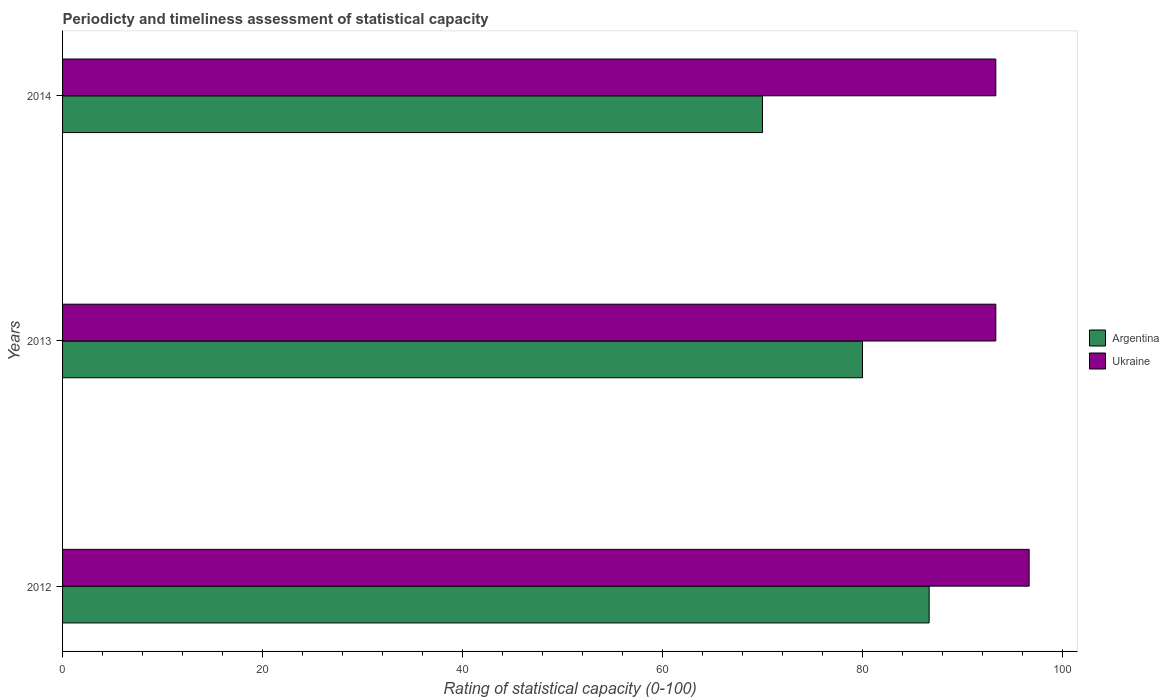How many different coloured bars are there?
Ensure brevity in your answer.  2. Are the number of bars per tick equal to the number of legend labels?
Give a very brief answer. Yes. What is the label of the 1st group of bars from the top?
Offer a very short reply. 2014. In how many cases, is the number of bars for a given year not equal to the number of legend labels?
Your response must be concise. 0. What is the rating of statistical capacity in Ukraine in 2012?
Your answer should be compact. 96.67. Across all years, what is the maximum rating of statistical capacity in Ukraine?
Offer a terse response. 96.67. Across all years, what is the minimum rating of statistical capacity in Ukraine?
Your answer should be very brief. 93.33. In which year was the rating of statistical capacity in Ukraine maximum?
Offer a very short reply. 2012. What is the total rating of statistical capacity in Argentina in the graph?
Offer a very short reply. 236.67. What is the difference between the rating of statistical capacity in Ukraine in 2012 and that in 2014?
Make the answer very short. 3.33. What is the difference between the rating of statistical capacity in Ukraine in 2014 and the rating of statistical capacity in Argentina in 2012?
Your answer should be compact. 6.67. What is the average rating of statistical capacity in Ukraine per year?
Make the answer very short. 94.44. In the year 2013, what is the difference between the rating of statistical capacity in Argentina and rating of statistical capacity in Ukraine?
Your answer should be compact. -13.33. What is the difference between the highest and the second highest rating of statistical capacity in Argentina?
Offer a very short reply. 6.67. What is the difference between the highest and the lowest rating of statistical capacity in Ukraine?
Provide a succinct answer. 3.33. In how many years, is the rating of statistical capacity in Argentina greater than the average rating of statistical capacity in Argentina taken over all years?
Offer a terse response. 2. What does the 2nd bar from the top in 2014 represents?
Provide a short and direct response. Argentina. What does the 2nd bar from the bottom in 2013 represents?
Your answer should be very brief. Ukraine. How many bars are there?
Provide a succinct answer. 6. Are all the bars in the graph horizontal?
Keep it short and to the point. Yes. How many years are there in the graph?
Provide a short and direct response. 3. Are the values on the major ticks of X-axis written in scientific E-notation?
Provide a succinct answer. No. Does the graph contain any zero values?
Make the answer very short. No. Does the graph contain grids?
Your answer should be compact. No. Where does the legend appear in the graph?
Provide a succinct answer. Center right. How are the legend labels stacked?
Provide a succinct answer. Vertical. What is the title of the graph?
Keep it short and to the point. Periodicty and timeliness assessment of statistical capacity. What is the label or title of the X-axis?
Offer a terse response. Rating of statistical capacity (0-100). What is the label or title of the Y-axis?
Your answer should be compact. Years. What is the Rating of statistical capacity (0-100) of Argentina in 2012?
Give a very brief answer. 86.67. What is the Rating of statistical capacity (0-100) of Ukraine in 2012?
Give a very brief answer. 96.67. What is the Rating of statistical capacity (0-100) in Ukraine in 2013?
Keep it short and to the point. 93.33. What is the Rating of statistical capacity (0-100) in Argentina in 2014?
Offer a very short reply. 70. What is the Rating of statistical capacity (0-100) in Ukraine in 2014?
Your answer should be very brief. 93.33. Across all years, what is the maximum Rating of statistical capacity (0-100) of Argentina?
Provide a succinct answer. 86.67. Across all years, what is the maximum Rating of statistical capacity (0-100) in Ukraine?
Keep it short and to the point. 96.67. Across all years, what is the minimum Rating of statistical capacity (0-100) in Ukraine?
Provide a short and direct response. 93.33. What is the total Rating of statistical capacity (0-100) of Argentina in the graph?
Offer a terse response. 236.67. What is the total Rating of statistical capacity (0-100) of Ukraine in the graph?
Offer a terse response. 283.33. What is the difference between the Rating of statistical capacity (0-100) in Ukraine in 2012 and that in 2013?
Make the answer very short. 3.33. What is the difference between the Rating of statistical capacity (0-100) in Argentina in 2012 and that in 2014?
Provide a short and direct response. 16.67. What is the difference between the Rating of statistical capacity (0-100) in Ukraine in 2012 and that in 2014?
Give a very brief answer. 3.33. What is the difference between the Rating of statistical capacity (0-100) of Argentina in 2012 and the Rating of statistical capacity (0-100) of Ukraine in 2013?
Offer a terse response. -6.67. What is the difference between the Rating of statistical capacity (0-100) in Argentina in 2012 and the Rating of statistical capacity (0-100) in Ukraine in 2014?
Offer a very short reply. -6.67. What is the difference between the Rating of statistical capacity (0-100) of Argentina in 2013 and the Rating of statistical capacity (0-100) of Ukraine in 2014?
Provide a short and direct response. -13.33. What is the average Rating of statistical capacity (0-100) of Argentina per year?
Ensure brevity in your answer.  78.89. What is the average Rating of statistical capacity (0-100) of Ukraine per year?
Ensure brevity in your answer.  94.44. In the year 2013, what is the difference between the Rating of statistical capacity (0-100) in Argentina and Rating of statistical capacity (0-100) in Ukraine?
Offer a terse response. -13.33. In the year 2014, what is the difference between the Rating of statistical capacity (0-100) of Argentina and Rating of statistical capacity (0-100) of Ukraine?
Ensure brevity in your answer.  -23.33. What is the ratio of the Rating of statistical capacity (0-100) in Argentina in 2012 to that in 2013?
Provide a short and direct response. 1.08. What is the ratio of the Rating of statistical capacity (0-100) of Ukraine in 2012 to that in 2013?
Offer a very short reply. 1.04. What is the ratio of the Rating of statistical capacity (0-100) in Argentina in 2012 to that in 2014?
Your response must be concise. 1.24. What is the ratio of the Rating of statistical capacity (0-100) in Ukraine in 2012 to that in 2014?
Your answer should be compact. 1.04. What is the ratio of the Rating of statistical capacity (0-100) in Argentina in 2013 to that in 2014?
Ensure brevity in your answer.  1.14. What is the difference between the highest and the second highest Rating of statistical capacity (0-100) of Ukraine?
Your response must be concise. 3.33. What is the difference between the highest and the lowest Rating of statistical capacity (0-100) of Argentina?
Give a very brief answer. 16.67. 